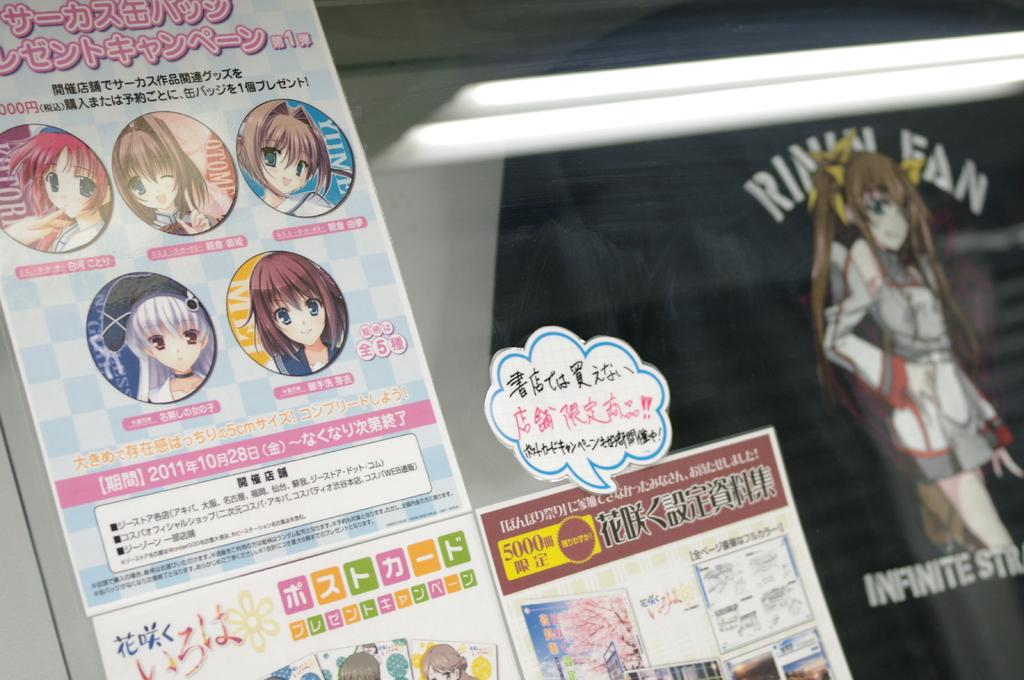What can be seen on the posts in the image? There are posts with text and images in the image. Can you describe the object in the background? There is a black color object in the background that looks like a shirt with text and an image. What type of net is being used for the operation in the image? There is no operation or net present in the image; it only features posts with text and images and a black shirt in the background. 